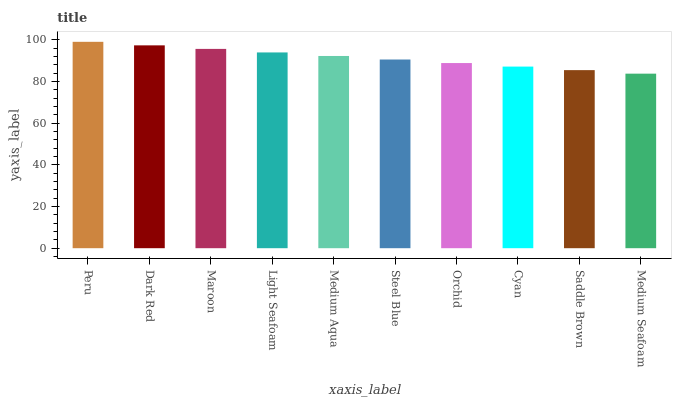Is Medium Seafoam the minimum?
Answer yes or no. Yes. Is Peru the maximum?
Answer yes or no. Yes. Is Dark Red the minimum?
Answer yes or no. No. Is Dark Red the maximum?
Answer yes or no. No. Is Peru greater than Dark Red?
Answer yes or no. Yes. Is Dark Red less than Peru?
Answer yes or no. Yes. Is Dark Red greater than Peru?
Answer yes or no. No. Is Peru less than Dark Red?
Answer yes or no. No. Is Medium Aqua the high median?
Answer yes or no. Yes. Is Steel Blue the low median?
Answer yes or no. Yes. Is Cyan the high median?
Answer yes or no. No. Is Medium Aqua the low median?
Answer yes or no. No. 